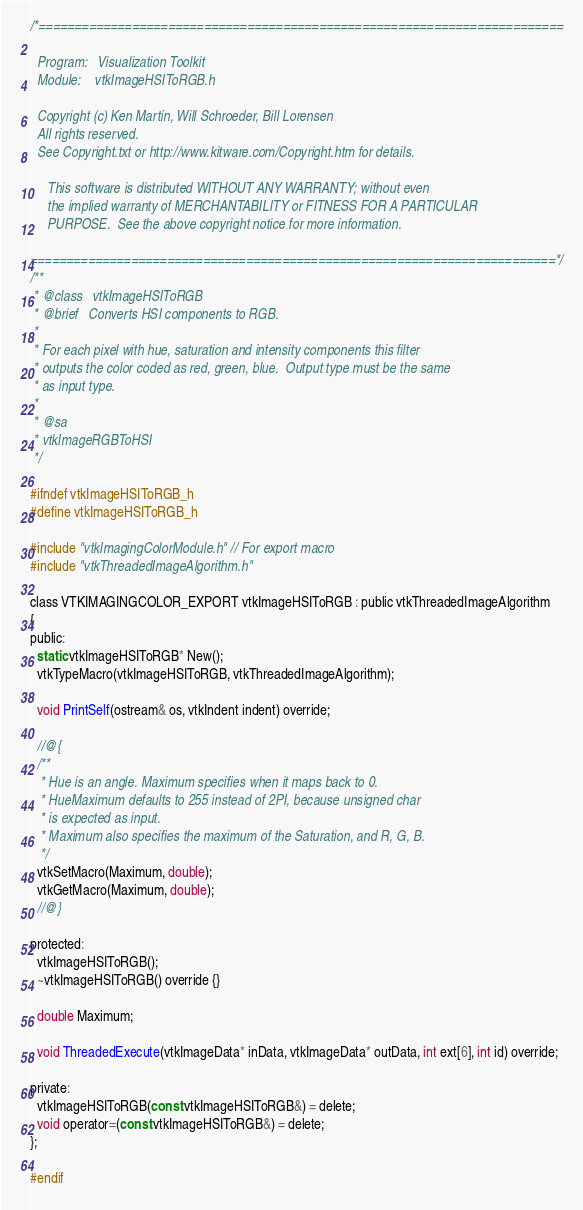Convert code to text. <code><loc_0><loc_0><loc_500><loc_500><_C_>/*=========================================================================

  Program:   Visualization Toolkit
  Module:    vtkImageHSIToRGB.h

  Copyright (c) Ken Martin, Will Schroeder, Bill Lorensen
  All rights reserved.
  See Copyright.txt or http://www.kitware.com/Copyright.htm for details.

     This software is distributed WITHOUT ANY WARRANTY; without even
     the implied warranty of MERCHANTABILITY or FITNESS FOR A PARTICULAR
     PURPOSE.  See the above copyright notice for more information.

=========================================================================*/
/**
 * @class   vtkImageHSIToRGB
 * @brief   Converts HSI components to RGB.
 *
 * For each pixel with hue, saturation and intensity components this filter
 * outputs the color coded as red, green, blue.  Output type must be the same
 * as input type.
 *
 * @sa
 * vtkImageRGBToHSI
 */

#ifndef vtkImageHSIToRGB_h
#define vtkImageHSIToRGB_h

#include "vtkImagingColorModule.h" // For export macro
#include "vtkThreadedImageAlgorithm.h"

class VTKIMAGINGCOLOR_EXPORT vtkImageHSIToRGB : public vtkThreadedImageAlgorithm
{
public:
  static vtkImageHSIToRGB* New();
  vtkTypeMacro(vtkImageHSIToRGB, vtkThreadedImageAlgorithm);

  void PrintSelf(ostream& os, vtkIndent indent) override;

  //@{
  /**
   * Hue is an angle. Maximum specifies when it maps back to 0.
   * HueMaximum defaults to 255 instead of 2PI, because unsigned char
   * is expected as input.
   * Maximum also specifies the maximum of the Saturation, and R, G, B.
   */
  vtkSetMacro(Maximum, double);
  vtkGetMacro(Maximum, double);
  //@}

protected:
  vtkImageHSIToRGB();
  ~vtkImageHSIToRGB() override {}

  double Maximum;

  void ThreadedExecute(vtkImageData* inData, vtkImageData* outData, int ext[6], int id) override;

private:
  vtkImageHSIToRGB(const vtkImageHSIToRGB&) = delete;
  void operator=(const vtkImageHSIToRGB&) = delete;
};

#endif
</code> 